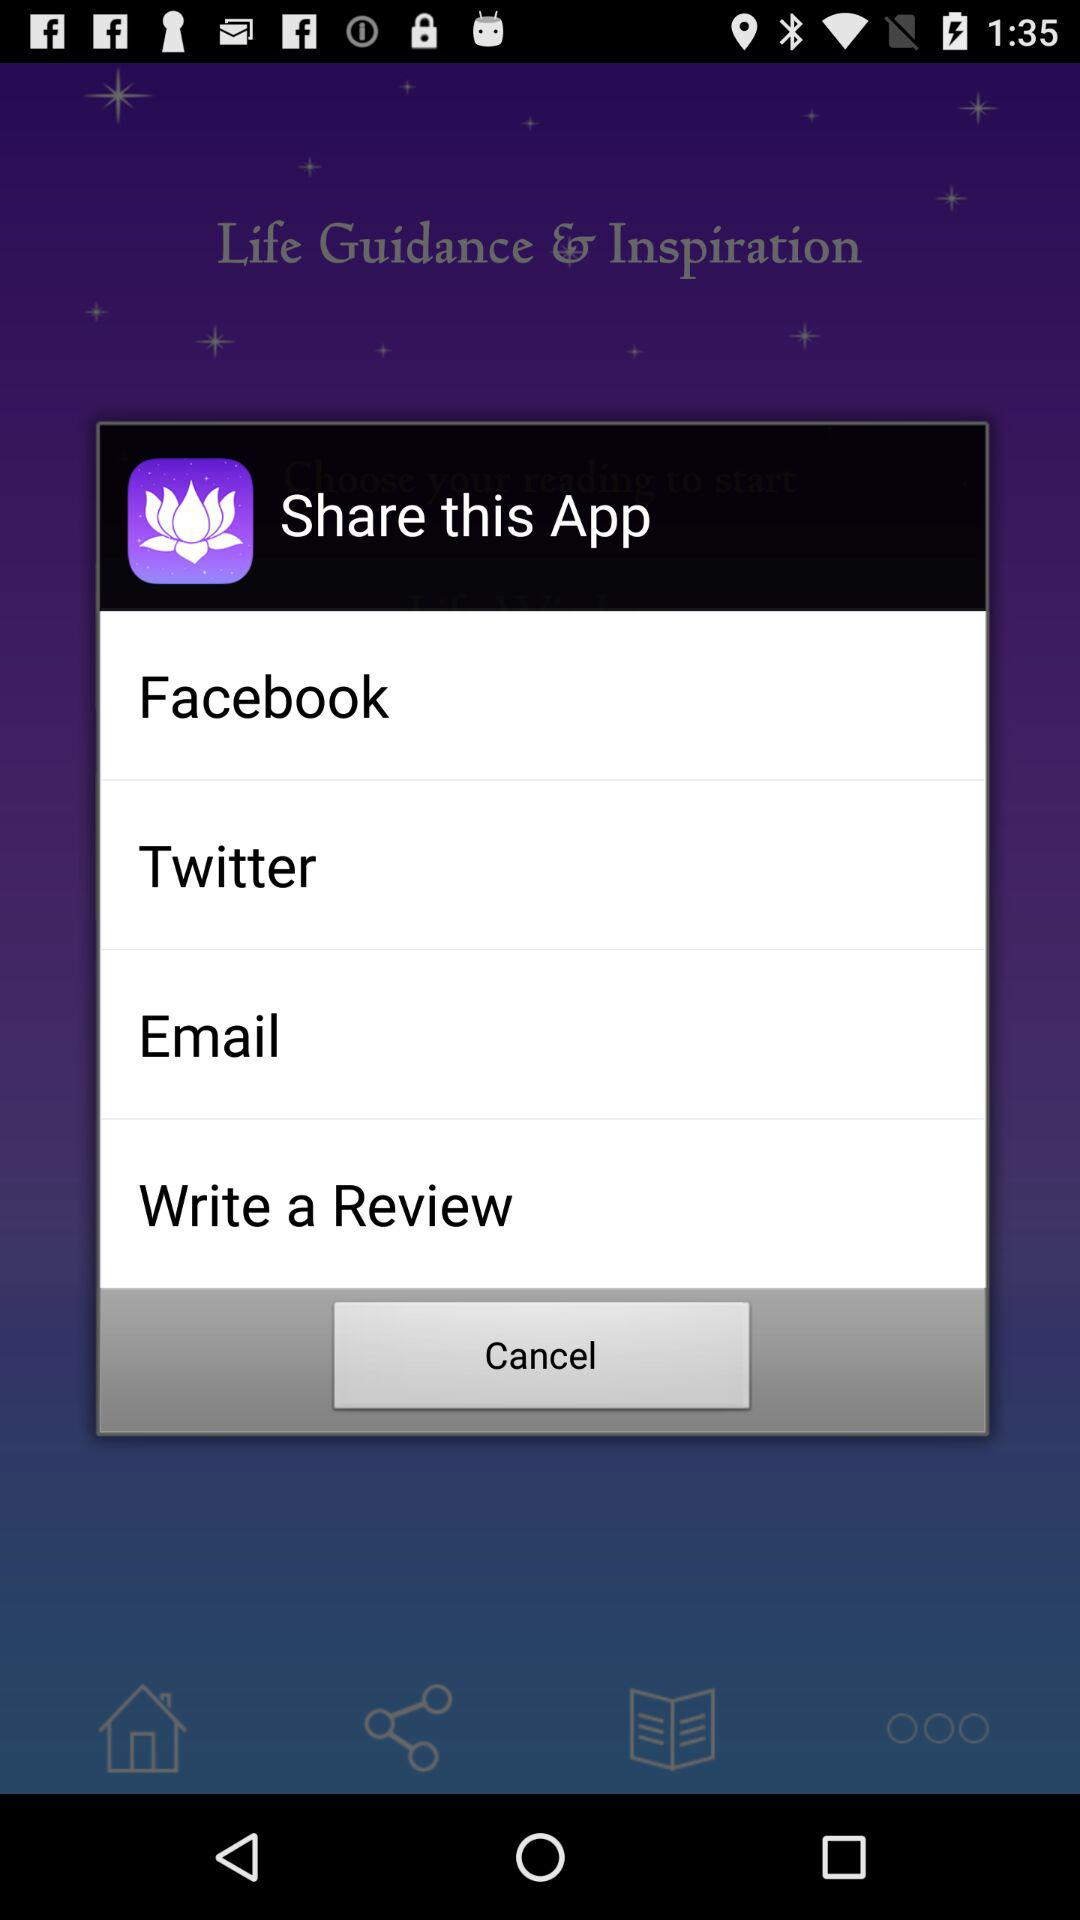Which applications can we use to share? You can use "Facebook" and "Twitter" applications to share. 